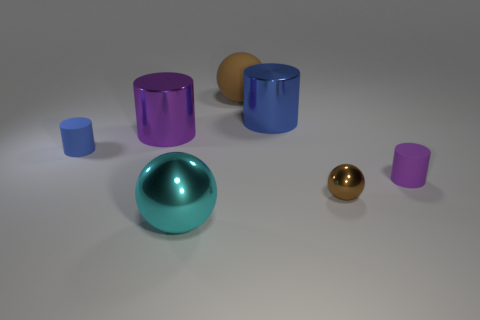There is a small thing that is the same color as the big rubber object; what is its shape?
Offer a terse response. Sphere. How many things are large green rubber blocks or matte cylinders that are to the left of the large cyan sphere?
Make the answer very short. 1. Is the color of the sphere on the right side of the brown rubber ball the same as the large matte sphere?
Keep it short and to the point. Yes. Are there more metallic spheres to the right of the blue matte cylinder than purple rubber things behind the small purple rubber cylinder?
Provide a succinct answer. Yes. Is there anything else of the same color as the big shiny ball?
Provide a succinct answer. No. How many things are tiny blue things or small red cylinders?
Make the answer very short. 1. Does the brown matte sphere that is to the left of the purple rubber cylinder have the same size as the large blue thing?
Your answer should be compact. Yes. How many other objects are the same size as the purple metallic cylinder?
Keep it short and to the point. 3. Are any big green rubber spheres visible?
Ensure brevity in your answer.  No. There is a brown sphere in front of the blue cylinder to the left of the big purple shiny object; what size is it?
Your answer should be compact. Small. 